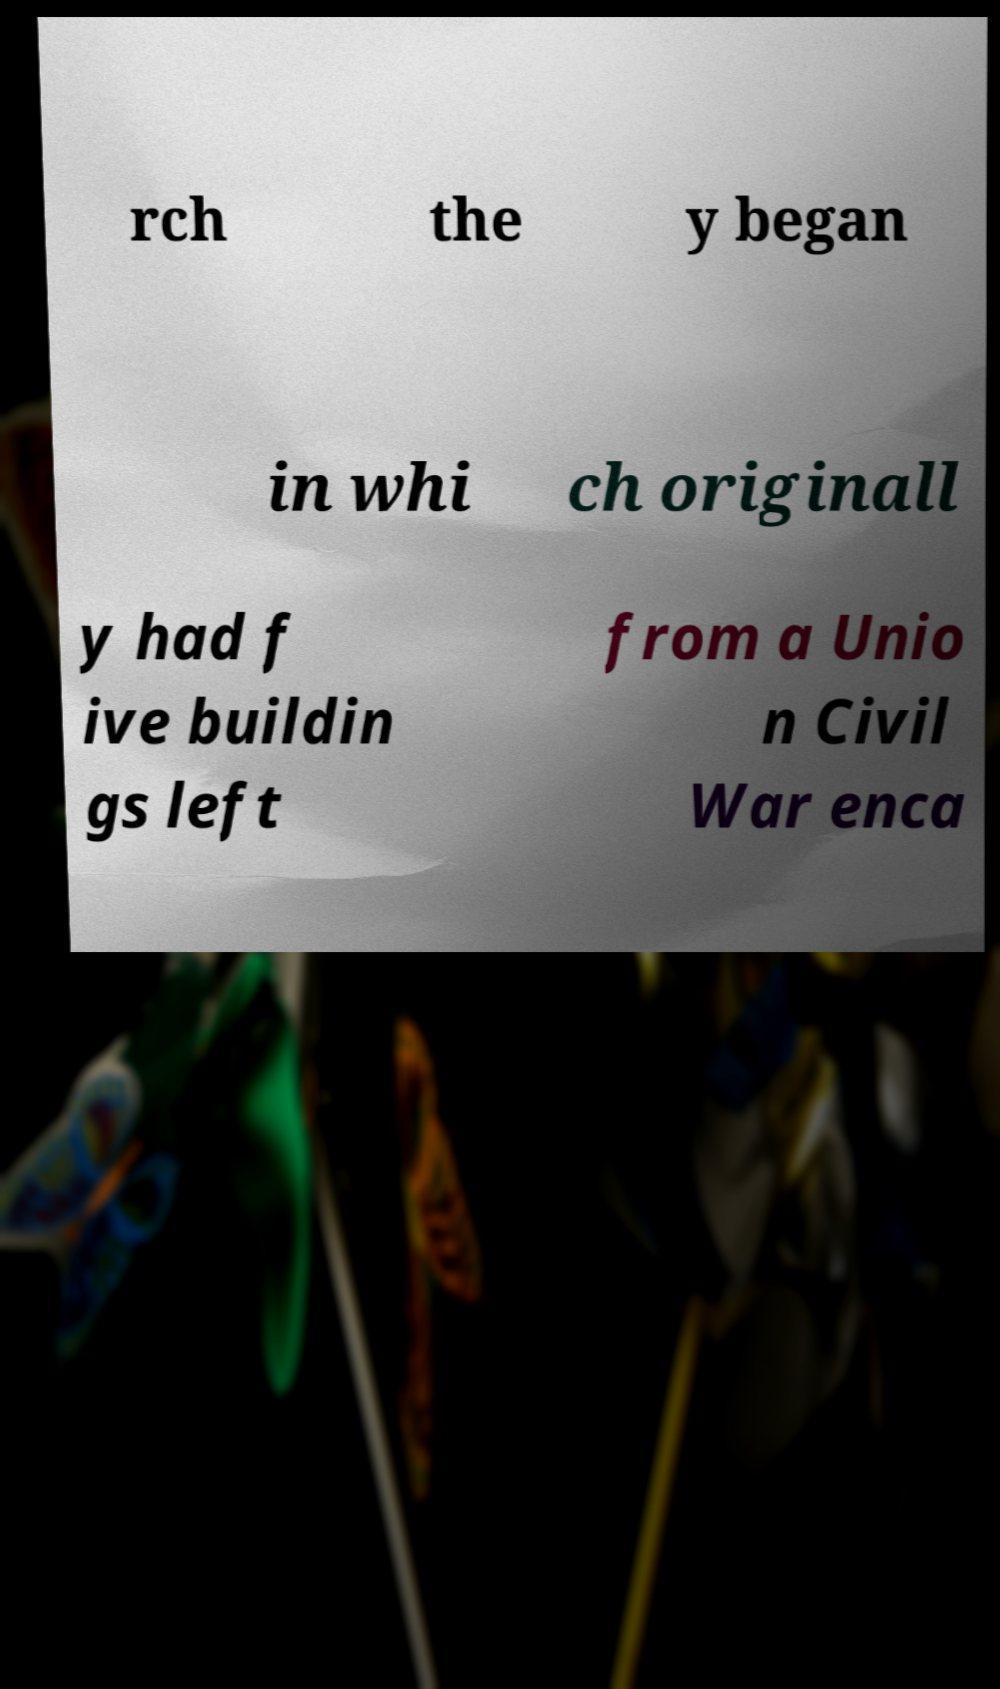For documentation purposes, I need the text within this image transcribed. Could you provide that? rch the y began in whi ch originall y had f ive buildin gs left from a Unio n Civil War enca 